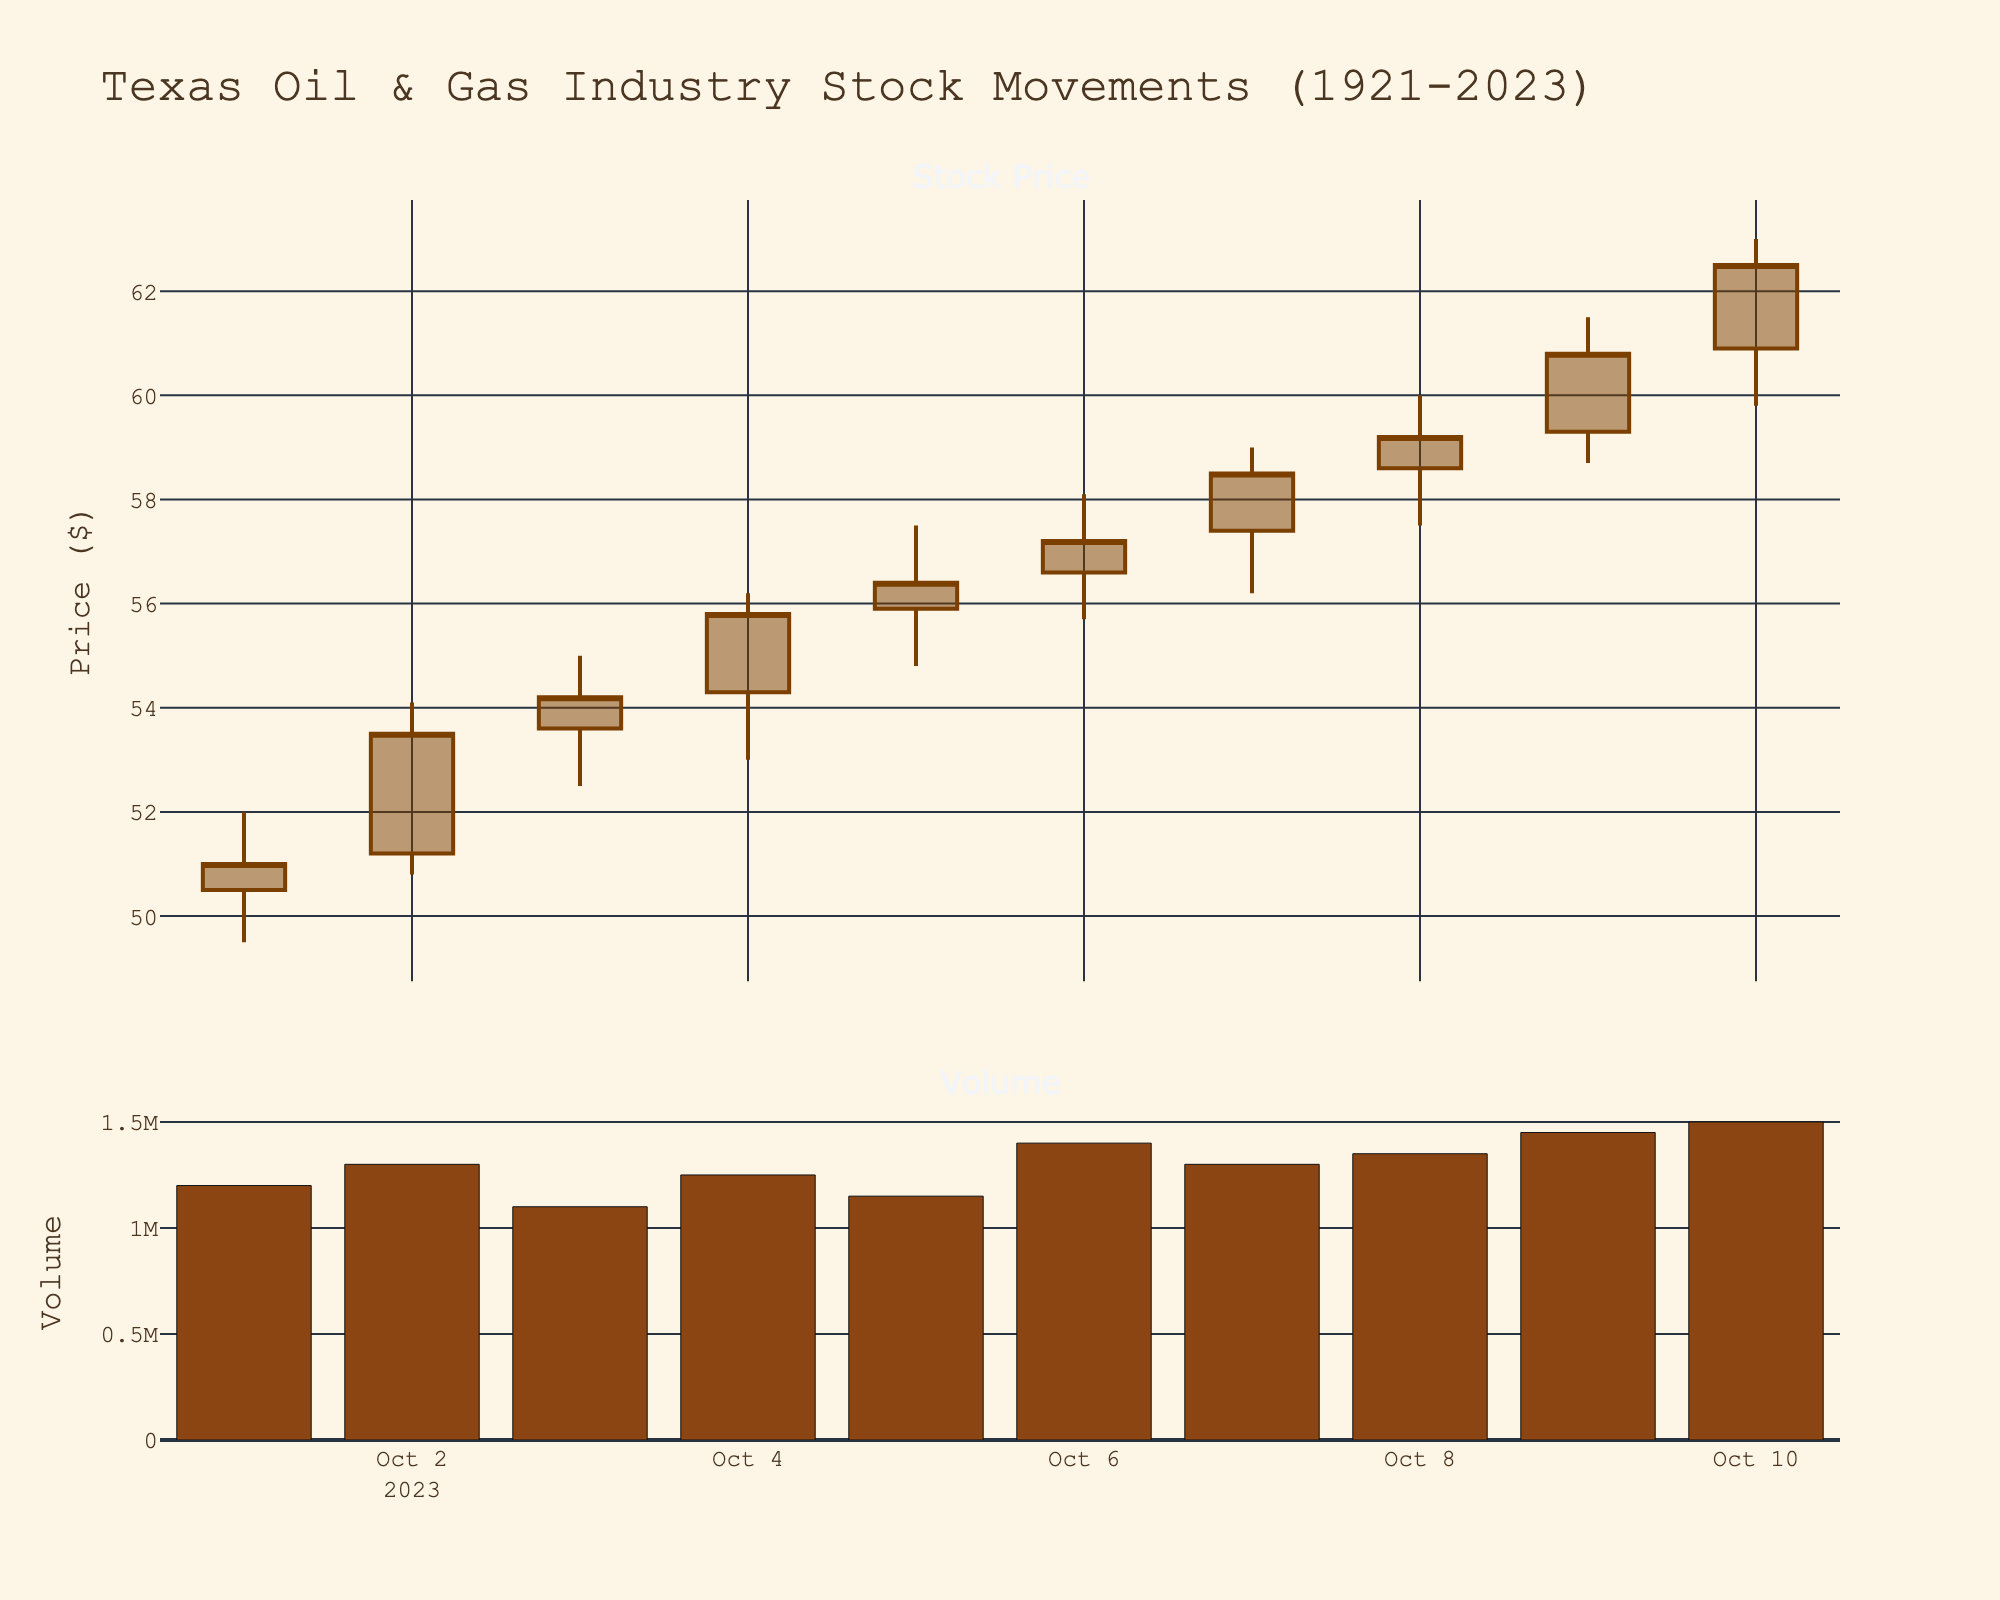What's the title of the plot? The title is typically at the top of the plot and summarizes what the plot is about. In this case, it states "Texas Oil & Gas Industry Stock Movements (1921-2023)"
Answer: Texas Oil & Gas Industry Stock Movements (1921-2023) What colors are used for the increasing and decreasing lines in the candlestick plot? The increasing lines are in brown, and the decreasing lines are in a darker brown. These colors help distinguish between days when the stock price increased and when it decreased.
Answer: brown, dark brown How many days show an increase in the closing stock price compared to the previous day? Identify the days when the closing price is higher than the previous day's closing price. Count these days: Oct 2, Oct 3, Oct 4, Oct 5, Oct 6, Oct 7, Oct 8, Oct 9, and Oct 10.
Answer: 9 What's the highest closing stock price recorded in the data? Look at the closing prices for each day and identify the highest value. The highest closing price is on Oct 10 at $62.50.
Answer: $62.50 On which date was the stock volume the highest? Look at the volume subplot and identify the bar with the highest height. This is on Oct 10, with a volume of 1,500,000.
Answer: October 10 What is the average stock trading volume over the 10 days? Sum up the volumes and divide by the number of days: (1,200,000 + 1,300,000 + 1,100,000 + 1,250,000 + 1,150,000 + 1,400,000 + 1,300,000 + 1,350,000 + 1,450,000 + 1,500,000)/10 = 1,300,000.
Answer: 1,300,000 On which date did the highest single-day price fluctuation occur? Calculate the difference between the highest and lowest price for each day, then identify the day with the highest difference. For example: Oct 10: $63.00 - $59.80 = $3.20. Compare all days.
Answer: October 9 What was the total volume traded on October 5, October 6, and October 7 combined? Sum the volume for these three days: 1,150,000 (Oct 5) + 1,400,000 (Oct 6) + 1,300,000 (Oct 7) = 3,850,000.
Answer: 3,850,000 What is the average closing price for the first five days? Add up the closing prices for the first five days and divide by 5: ($51.00 + $53.50 + $54.20 + $55.80 + $56.40)/5 = 54.18.
Answer: $54.18 